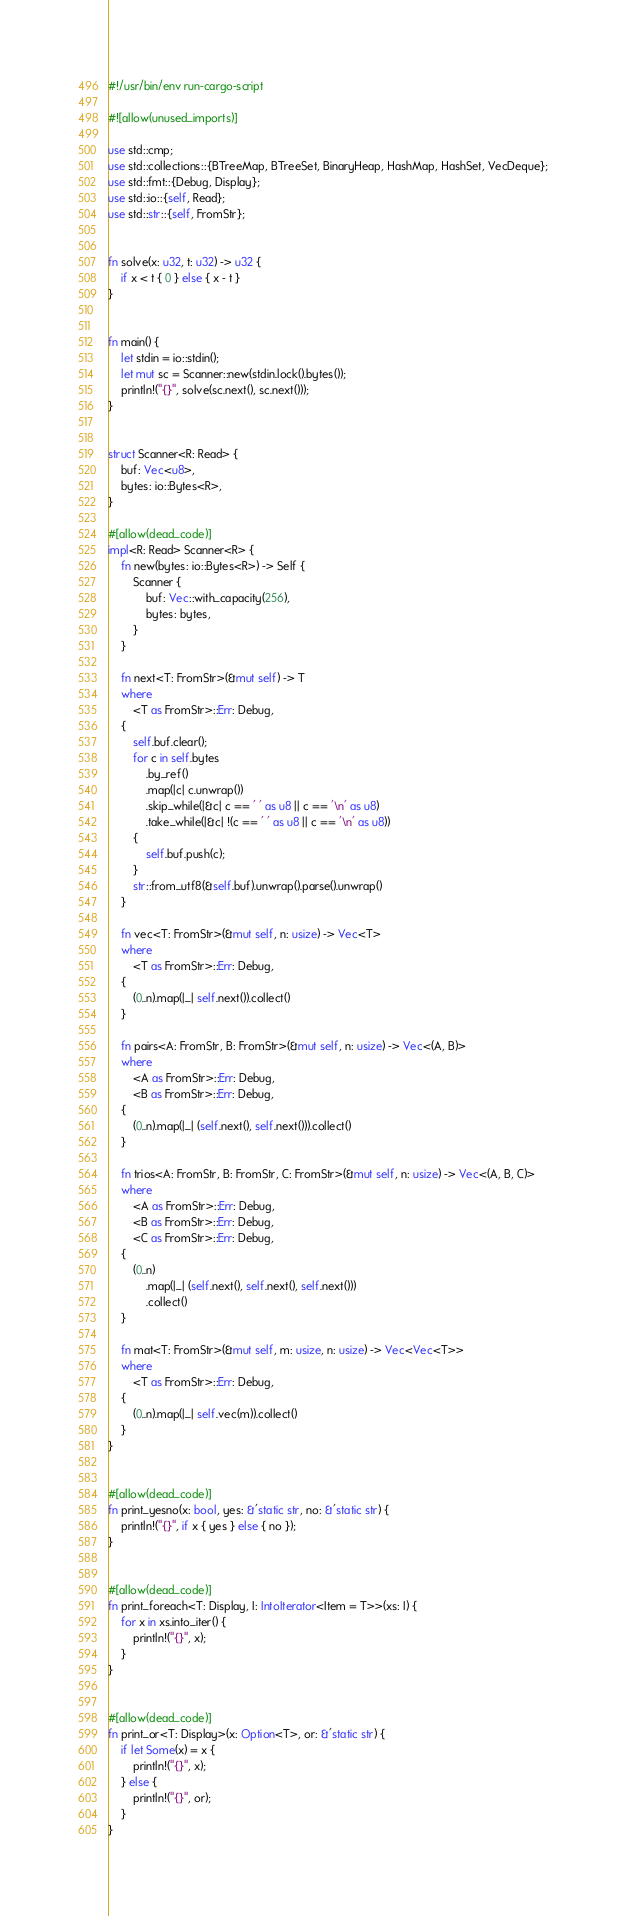<code> <loc_0><loc_0><loc_500><loc_500><_Rust_>#!/usr/bin/env run-cargo-script

#![allow(unused_imports)]

use std::cmp;
use std::collections::{BTreeMap, BTreeSet, BinaryHeap, HashMap, HashSet, VecDeque};
use std::fmt::{Debug, Display};
use std::io::{self, Read};
use std::str::{self, FromStr};


fn solve(x: u32, t: u32) -> u32 {
    if x < t { 0 } else { x - t }
}


fn main() {
    let stdin = io::stdin();
    let mut sc = Scanner::new(stdin.lock().bytes());
    println!("{}", solve(sc.next(), sc.next()));
}


struct Scanner<R: Read> {
    buf: Vec<u8>,
    bytes: io::Bytes<R>,
}

#[allow(dead_code)]
impl<R: Read> Scanner<R> {
    fn new(bytes: io::Bytes<R>) -> Self {
        Scanner {
            buf: Vec::with_capacity(256),
            bytes: bytes,
        }
    }

    fn next<T: FromStr>(&mut self) -> T
    where
        <T as FromStr>::Err: Debug,
    {
        self.buf.clear();
        for c in self.bytes
            .by_ref()
            .map(|c| c.unwrap())
            .skip_while(|&c| c == ' ' as u8 || c == '\n' as u8)
            .take_while(|&c| !(c == ' ' as u8 || c == '\n' as u8))
        {
            self.buf.push(c);
        }
        str::from_utf8(&self.buf).unwrap().parse().unwrap()
    }

    fn vec<T: FromStr>(&mut self, n: usize) -> Vec<T>
    where
        <T as FromStr>::Err: Debug,
    {
        (0..n).map(|_| self.next()).collect()
    }

    fn pairs<A: FromStr, B: FromStr>(&mut self, n: usize) -> Vec<(A, B)>
    where
        <A as FromStr>::Err: Debug,
        <B as FromStr>::Err: Debug,
    {
        (0..n).map(|_| (self.next(), self.next())).collect()
    }

    fn trios<A: FromStr, B: FromStr, C: FromStr>(&mut self, n: usize) -> Vec<(A, B, C)>
    where
        <A as FromStr>::Err: Debug,
        <B as FromStr>::Err: Debug,
        <C as FromStr>::Err: Debug,
    {
        (0..n)
            .map(|_| (self.next(), self.next(), self.next()))
            .collect()
    }

    fn mat<T: FromStr>(&mut self, m: usize, n: usize) -> Vec<Vec<T>>
    where
        <T as FromStr>::Err: Debug,
    {
        (0..n).map(|_| self.vec(m)).collect()
    }
}


#[allow(dead_code)]
fn print_yesno(x: bool, yes: &'static str, no: &'static str) {
    println!("{}", if x { yes } else { no });
}


#[allow(dead_code)]
fn print_foreach<T: Display, I: IntoIterator<Item = T>>(xs: I) {
    for x in xs.into_iter() {
        println!("{}", x);
    }
}


#[allow(dead_code)]
fn print_or<T: Display>(x: Option<T>, or: &'static str) {
    if let Some(x) = x {
        println!("{}", x);
    } else {
        println!("{}", or);
    }
}
</code> 